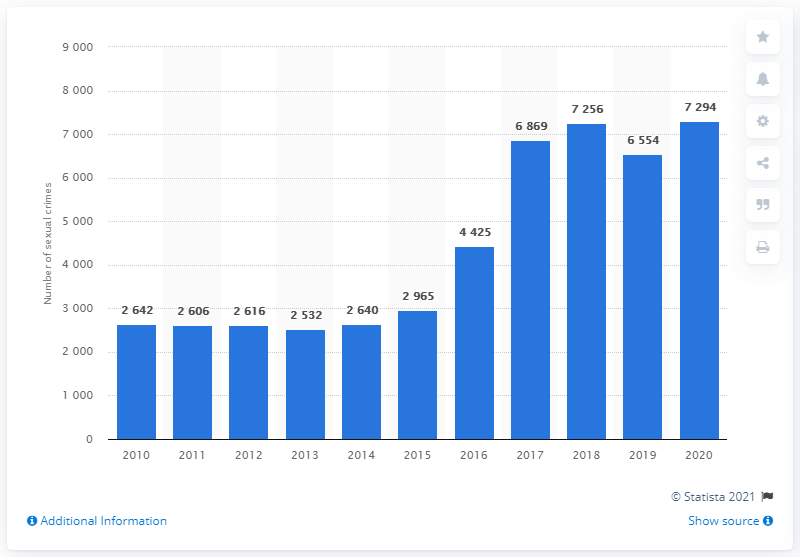What does this image suggest about the trend in sexual crimes in Denmark over the decade? The bar chart shows an overall increase in reported sexual crimes in Denmark over the last decade. Starting from 2,642 cases in 2010, there's a noticeable rise, with some fluctuations, peaking in 2020 with 7,294 cases. This suggests that either instances of sexual crimes have risen, reporting has become more prevalent, or a combination of both factors. 